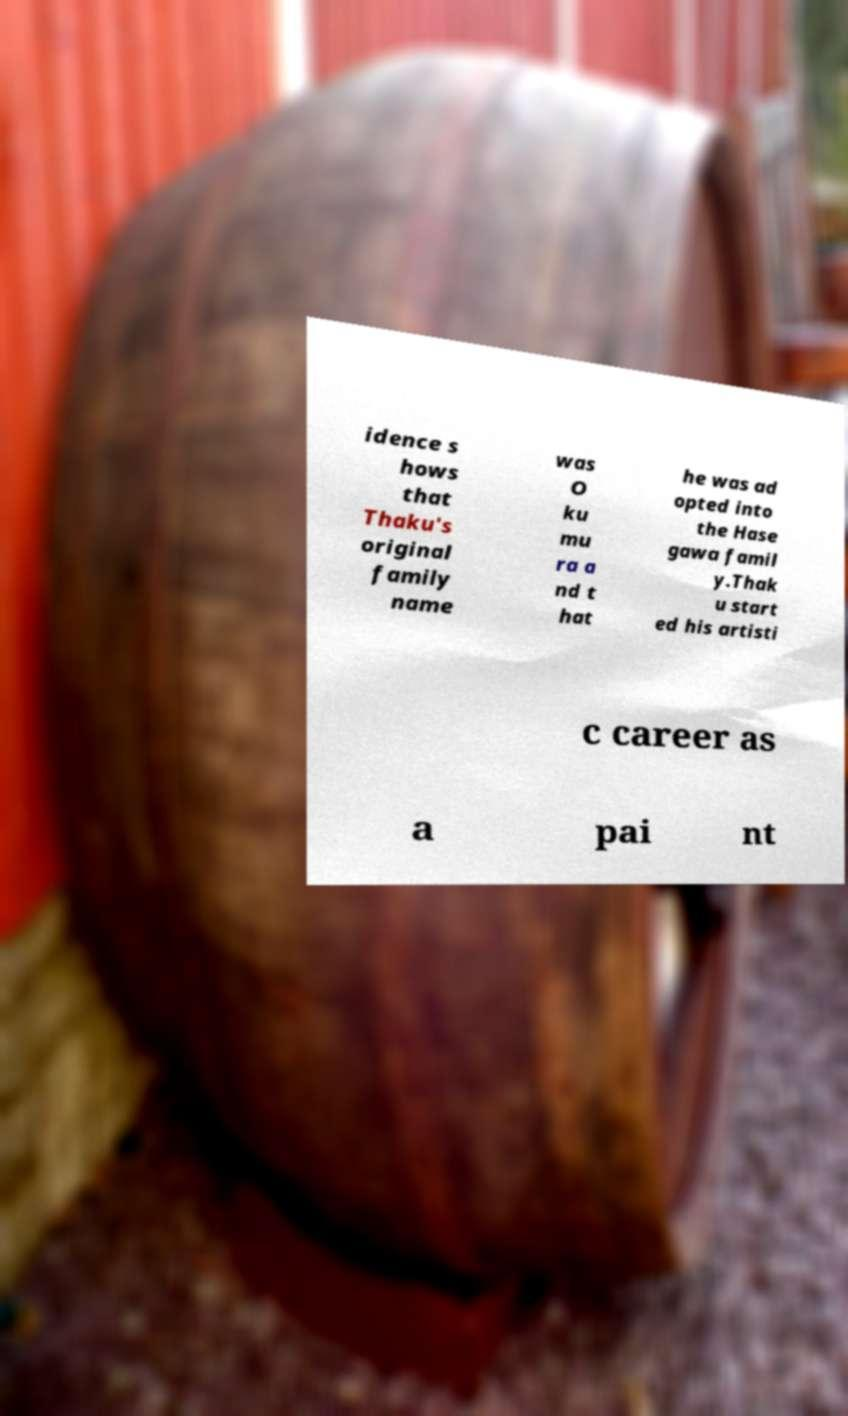Please read and relay the text visible in this image. What does it say? idence s hows that Thaku's original family name was O ku mu ra a nd t hat he was ad opted into the Hase gawa famil y.Thak u start ed his artisti c career as a pai nt 